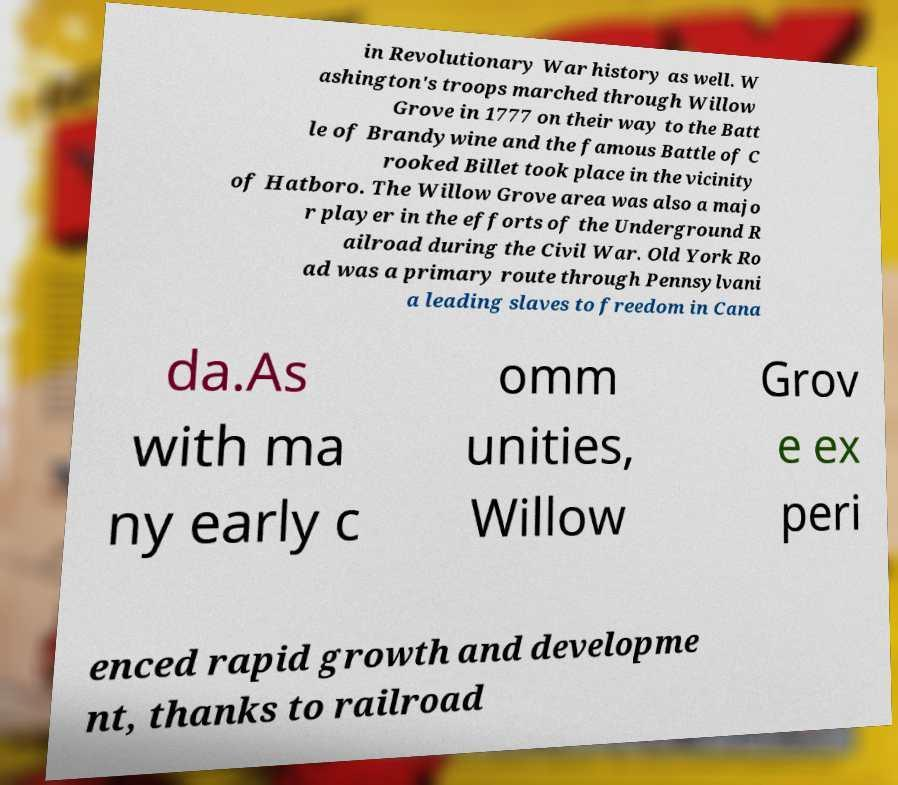Please read and relay the text visible in this image. What does it say? in Revolutionary War history as well. W ashington's troops marched through Willow Grove in 1777 on their way to the Batt le of Brandywine and the famous Battle of C rooked Billet took place in the vicinity of Hatboro. The Willow Grove area was also a majo r player in the efforts of the Underground R ailroad during the Civil War. Old York Ro ad was a primary route through Pennsylvani a leading slaves to freedom in Cana da.As with ma ny early c omm unities, Willow Grov e ex peri enced rapid growth and developme nt, thanks to railroad 